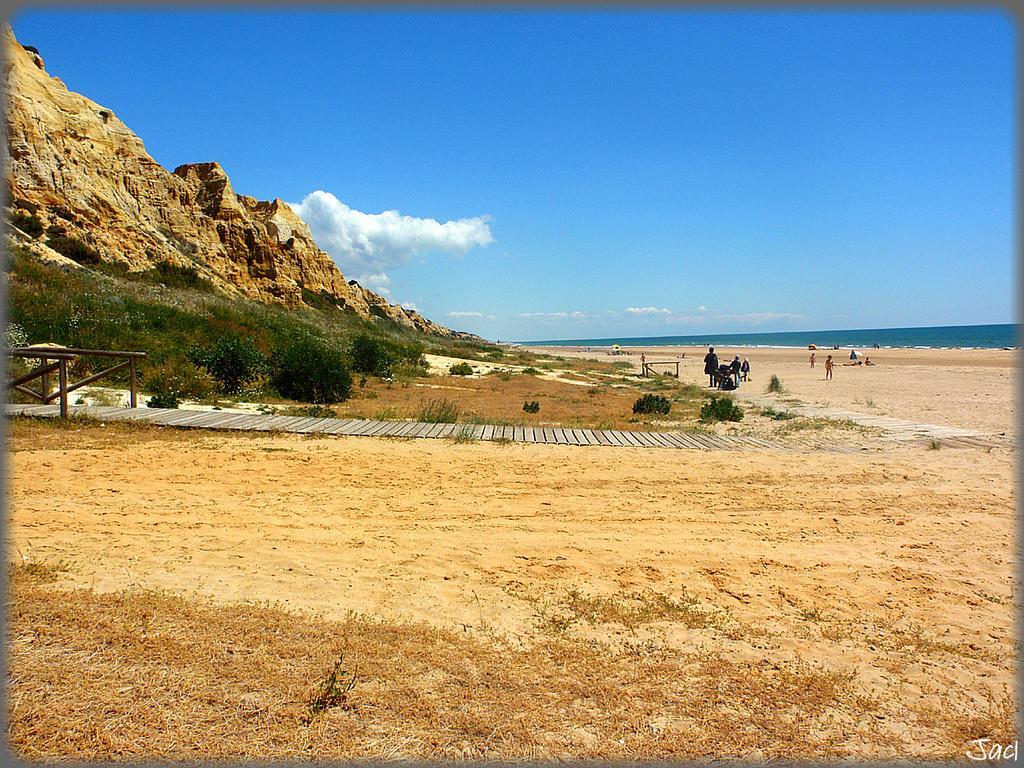Can you describe this image briefly? In this picture there is a cliff and greenery on the left side of the image and there are people in the image and there is water in the background area of the image and there is sky at the top side of the image. 